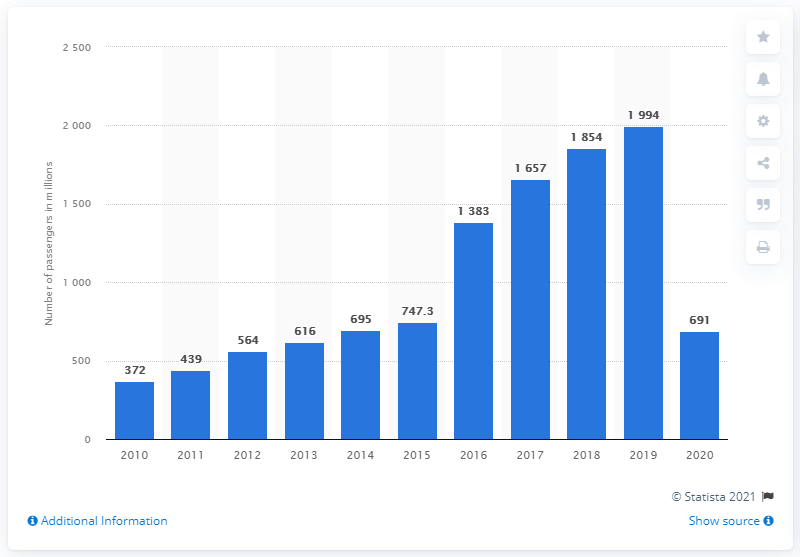Highlight a few significant elements in this photo. In 2020, a total of 691 air passengers boarded flights through bookings made using the Amadeus global distribution system. 